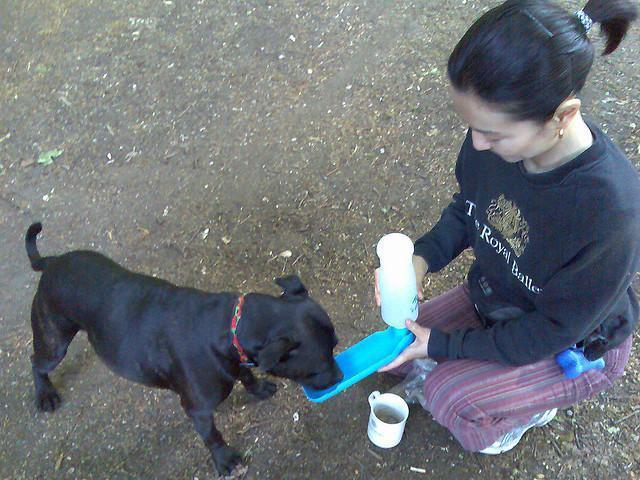How many people are there?
Give a very brief answer. 1. How many giraffe heads can you see?
Give a very brief answer. 0. 